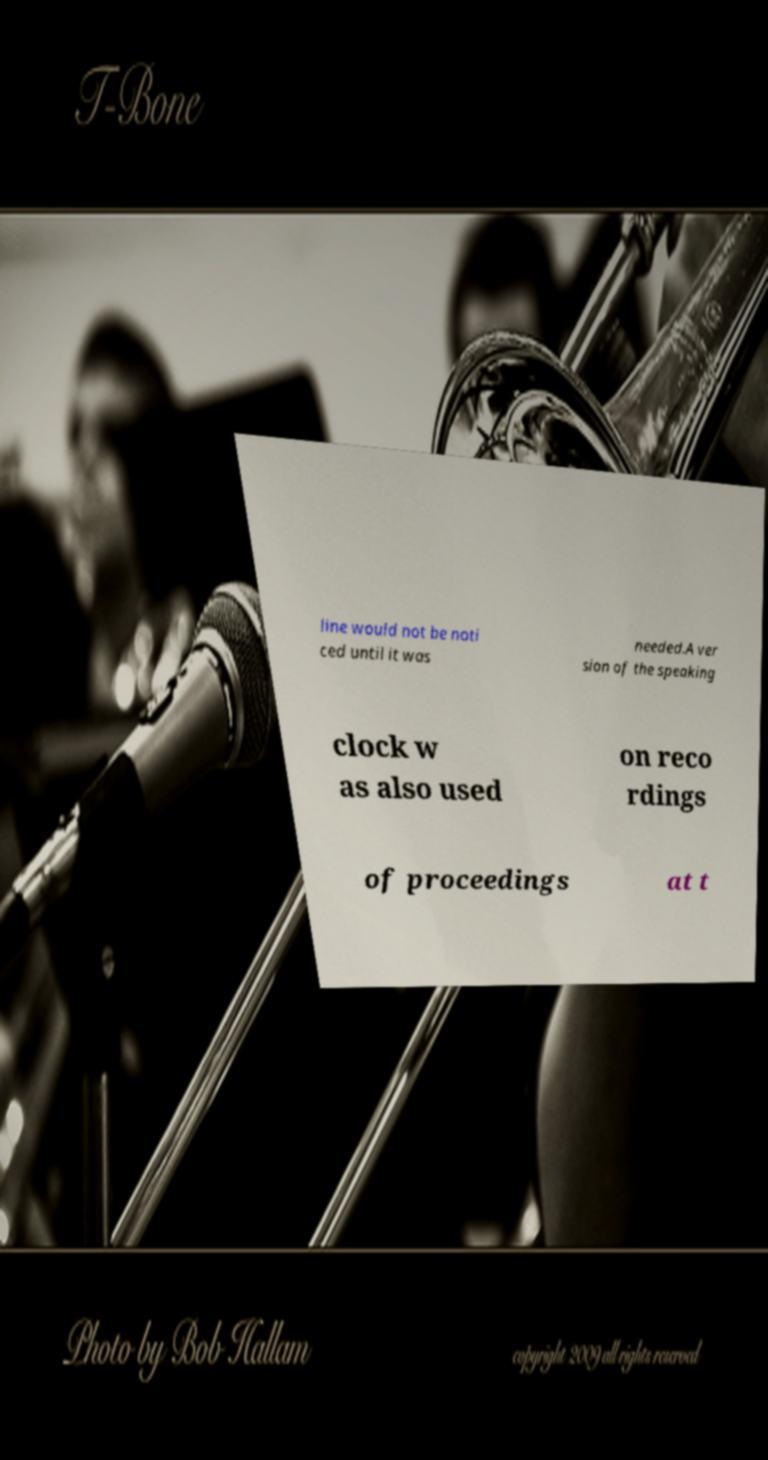I need the written content from this picture converted into text. Can you do that? line would not be noti ced until it was needed.A ver sion of the speaking clock w as also used on reco rdings of proceedings at t 